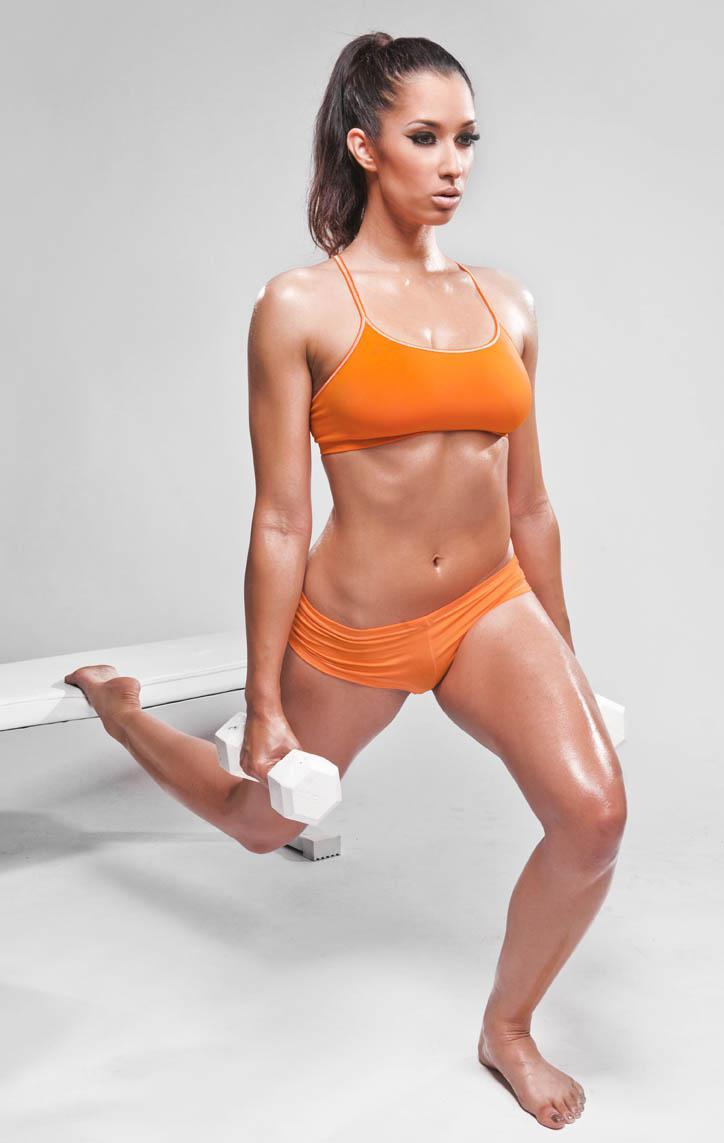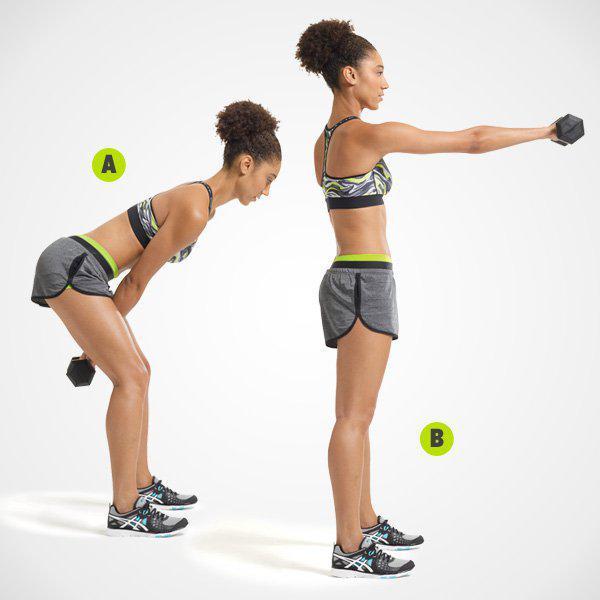The first image is the image on the left, the second image is the image on the right. Considering the images on both sides, is "Each image shows two steps of a weight workout, with a standing pose on the left and a crouched pose next to it." valid? Answer yes or no. No. The first image is the image on the left, the second image is the image on the right. For the images displayed, is the sentence "The left and right image contains the same number of  people working out with weights." factually correct? Answer yes or no. No. 